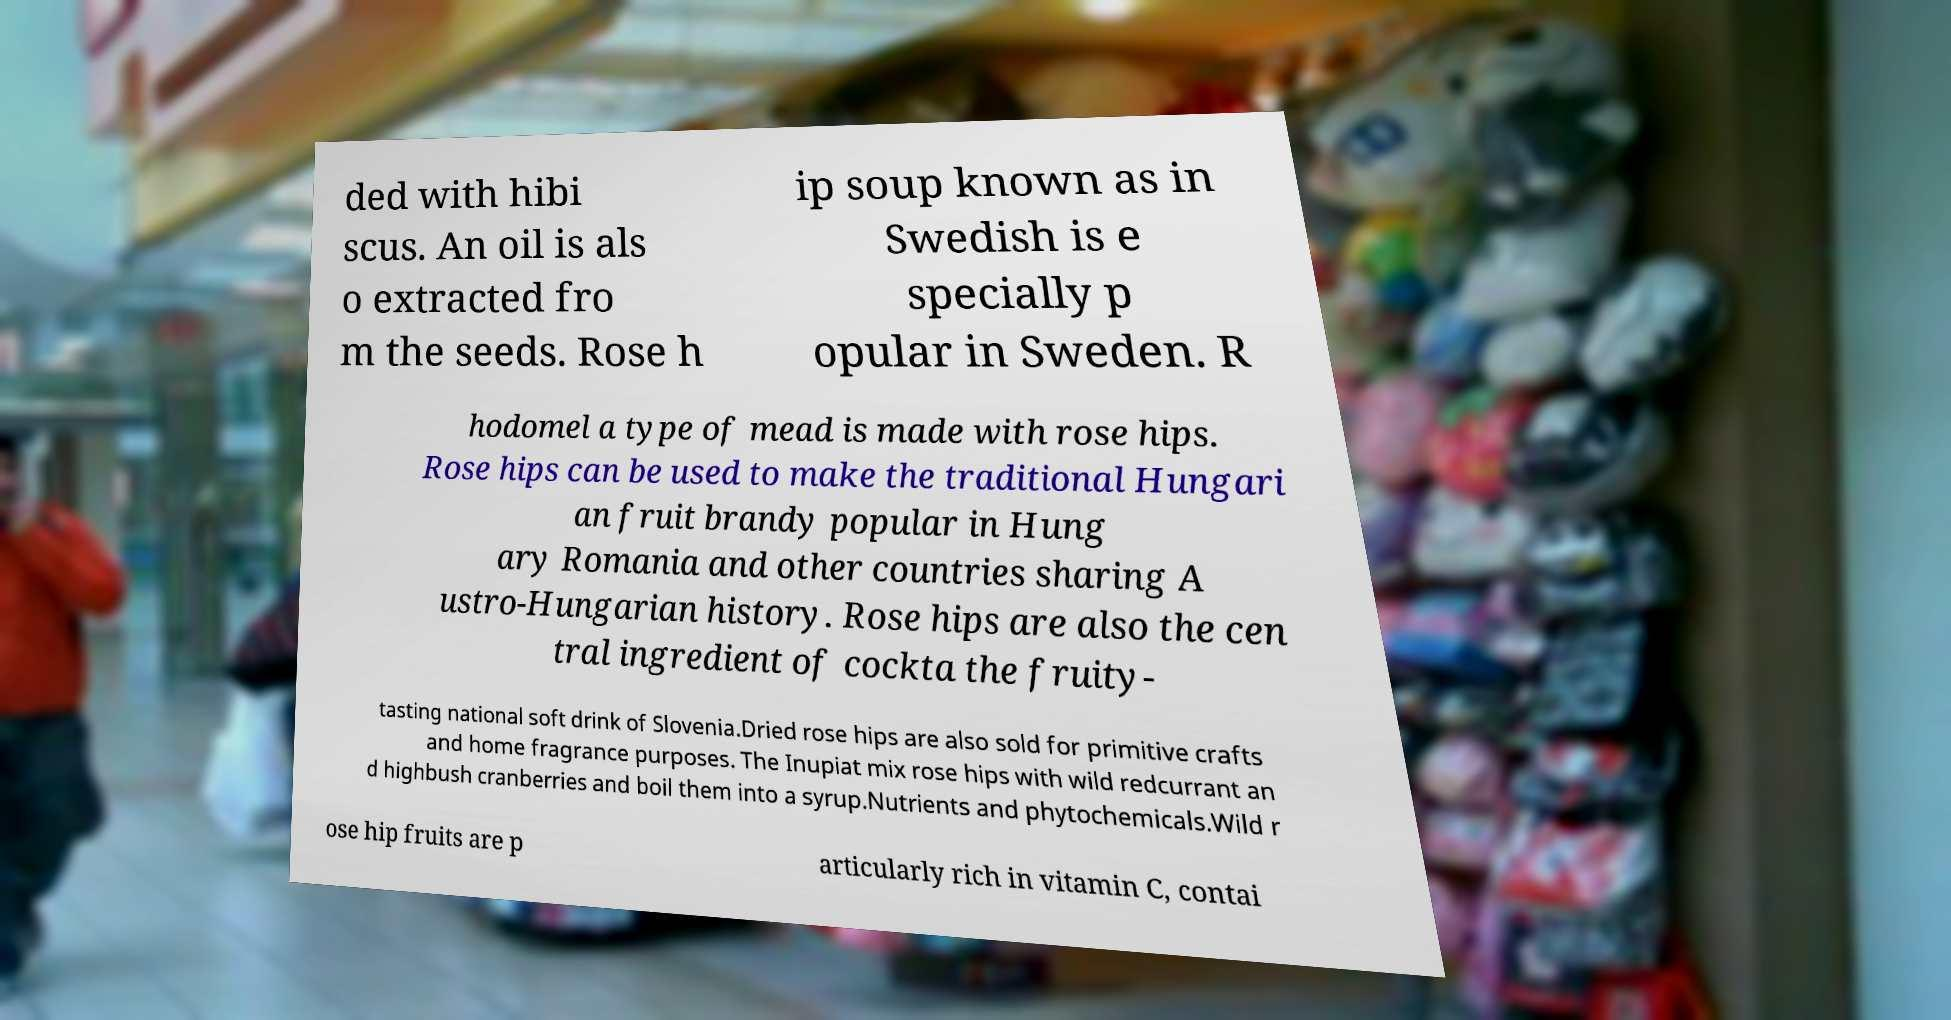Please read and relay the text visible in this image. What does it say? ded with hibi scus. An oil is als o extracted fro m the seeds. Rose h ip soup known as in Swedish is e specially p opular in Sweden. R hodomel a type of mead is made with rose hips. Rose hips can be used to make the traditional Hungari an fruit brandy popular in Hung ary Romania and other countries sharing A ustro-Hungarian history. Rose hips are also the cen tral ingredient of cockta the fruity- tasting national soft drink of Slovenia.Dried rose hips are also sold for primitive crafts and home fragrance purposes. The Inupiat mix rose hips with wild redcurrant an d highbush cranberries and boil them into a syrup.Nutrients and phytochemicals.Wild r ose hip fruits are p articularly rich in vitamin C, contai 